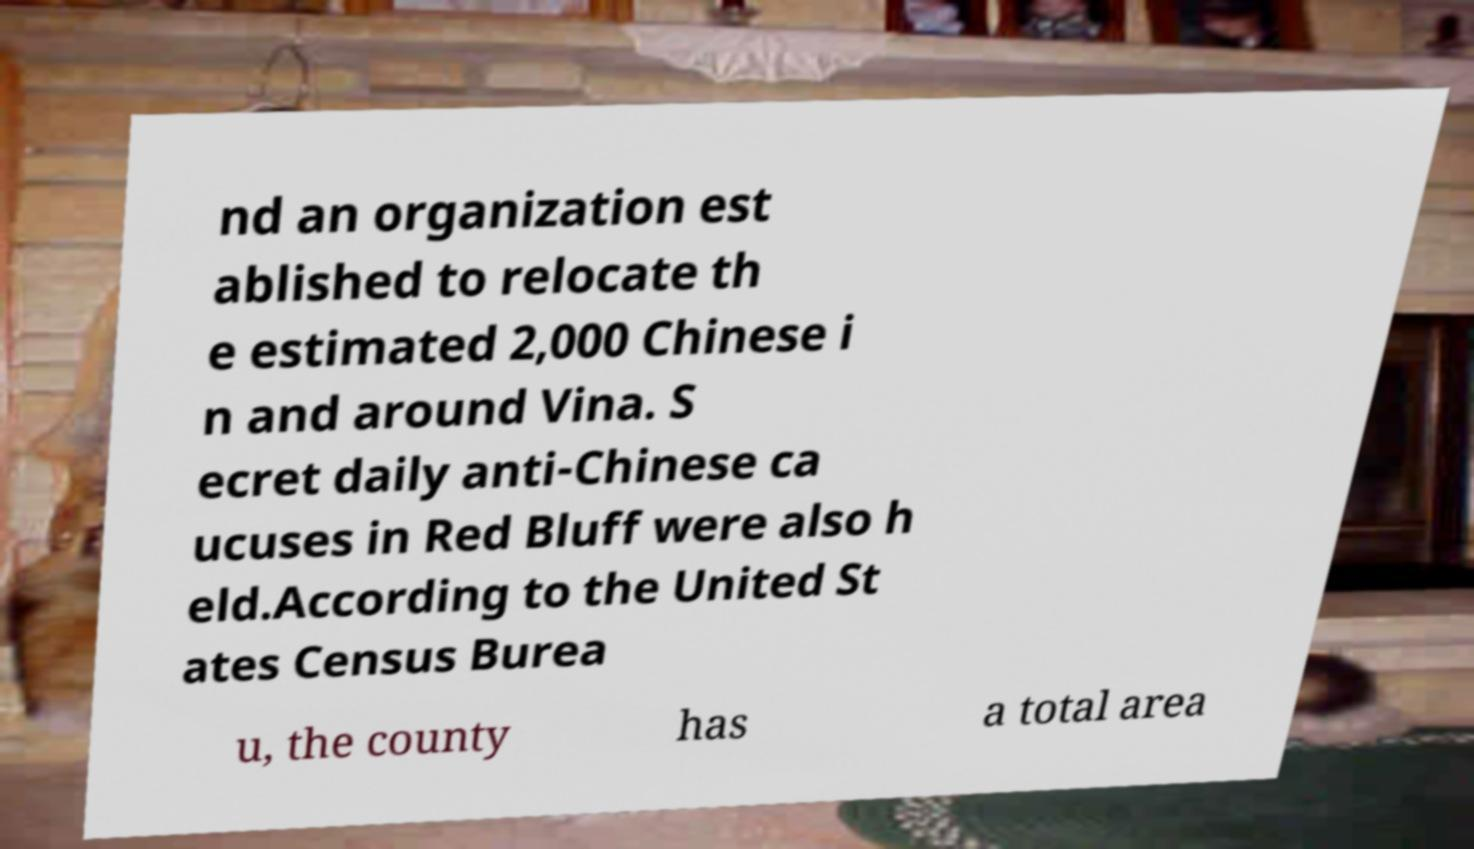Please identify and transcribe the text found in this image. nd an organization est ablished to relocate th e estimated 2,000 Chinese i n and around Vina. S ecret daily anti-Chinese ca ucuses in Red Bluff were also h eld.According to the United St ates Census Burea u, the county has a total area 